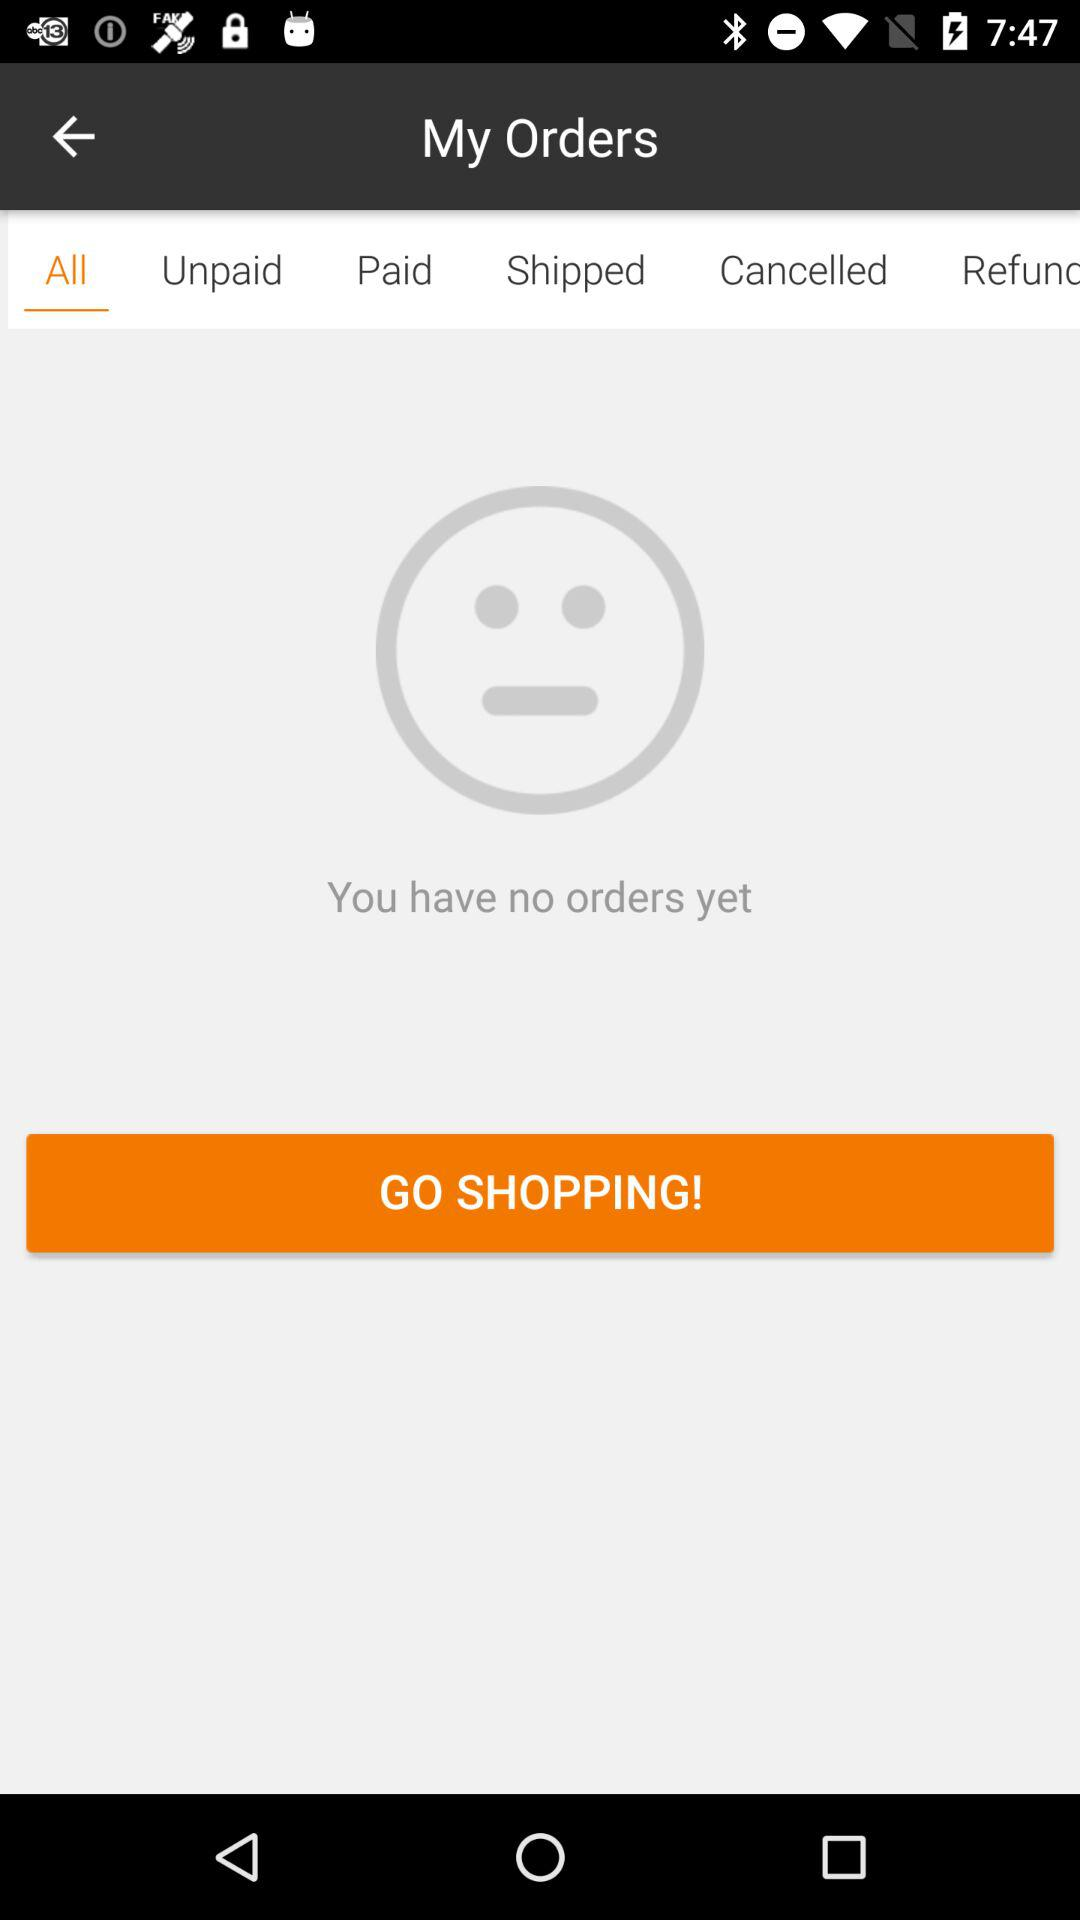Which option is selected? The selected option is "All". 